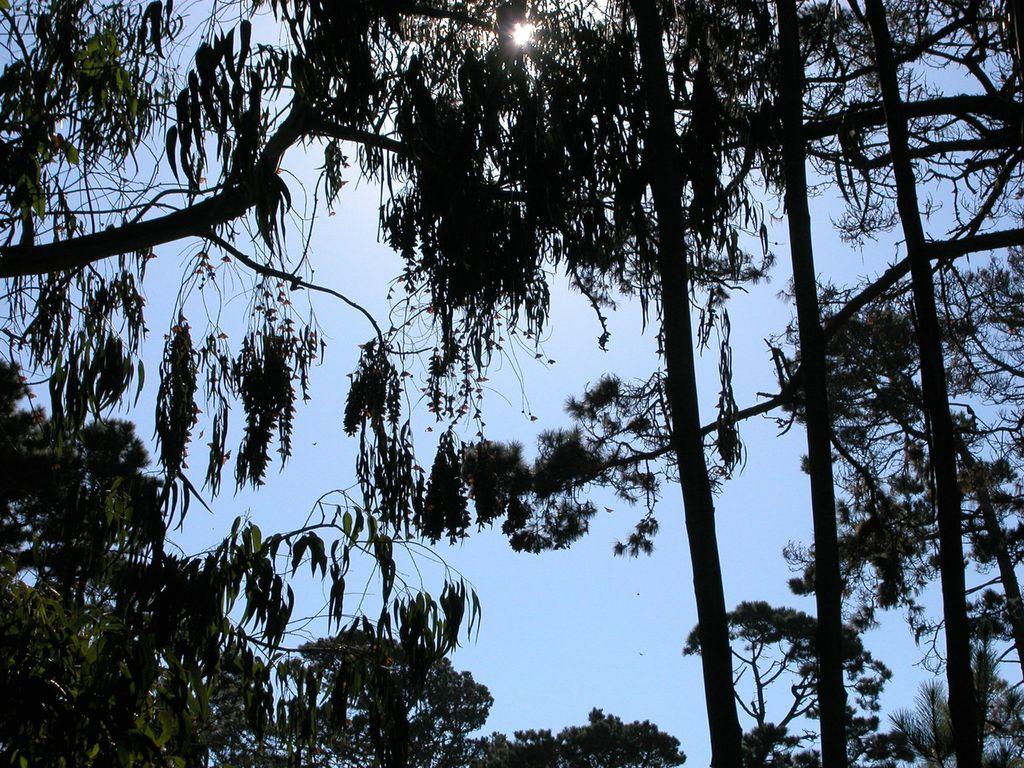What type of vegetation can be seen in the image? There are trees in the image. What part of the natural environment is visible in the image? The sky is visible in the background of the image. What advice does the mother give to her grandfather in the image? There is no mother or grandfather present in the image, so no such conversation can be observed. 